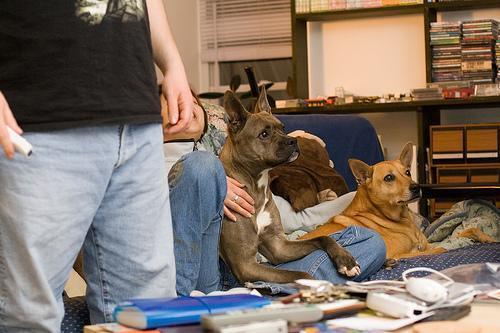How many dogs are in the picture?
Give a very brief answer. 2. 